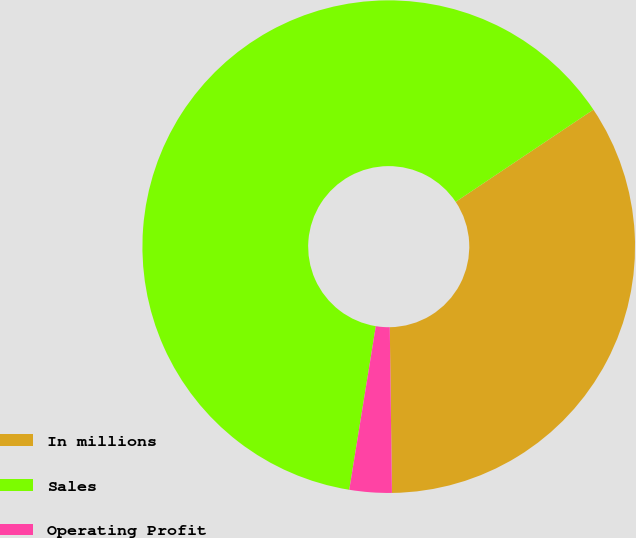Convert chart to OTSL. <chart><loc_0><loc_0><loc_500><loc_500><pie_chart><fcel>In millions<fcel>Sales<fcel>Operating Profit<nl><fcel>34.18%<fcel>63.05%<fcel>2.77%<nl></chart> 